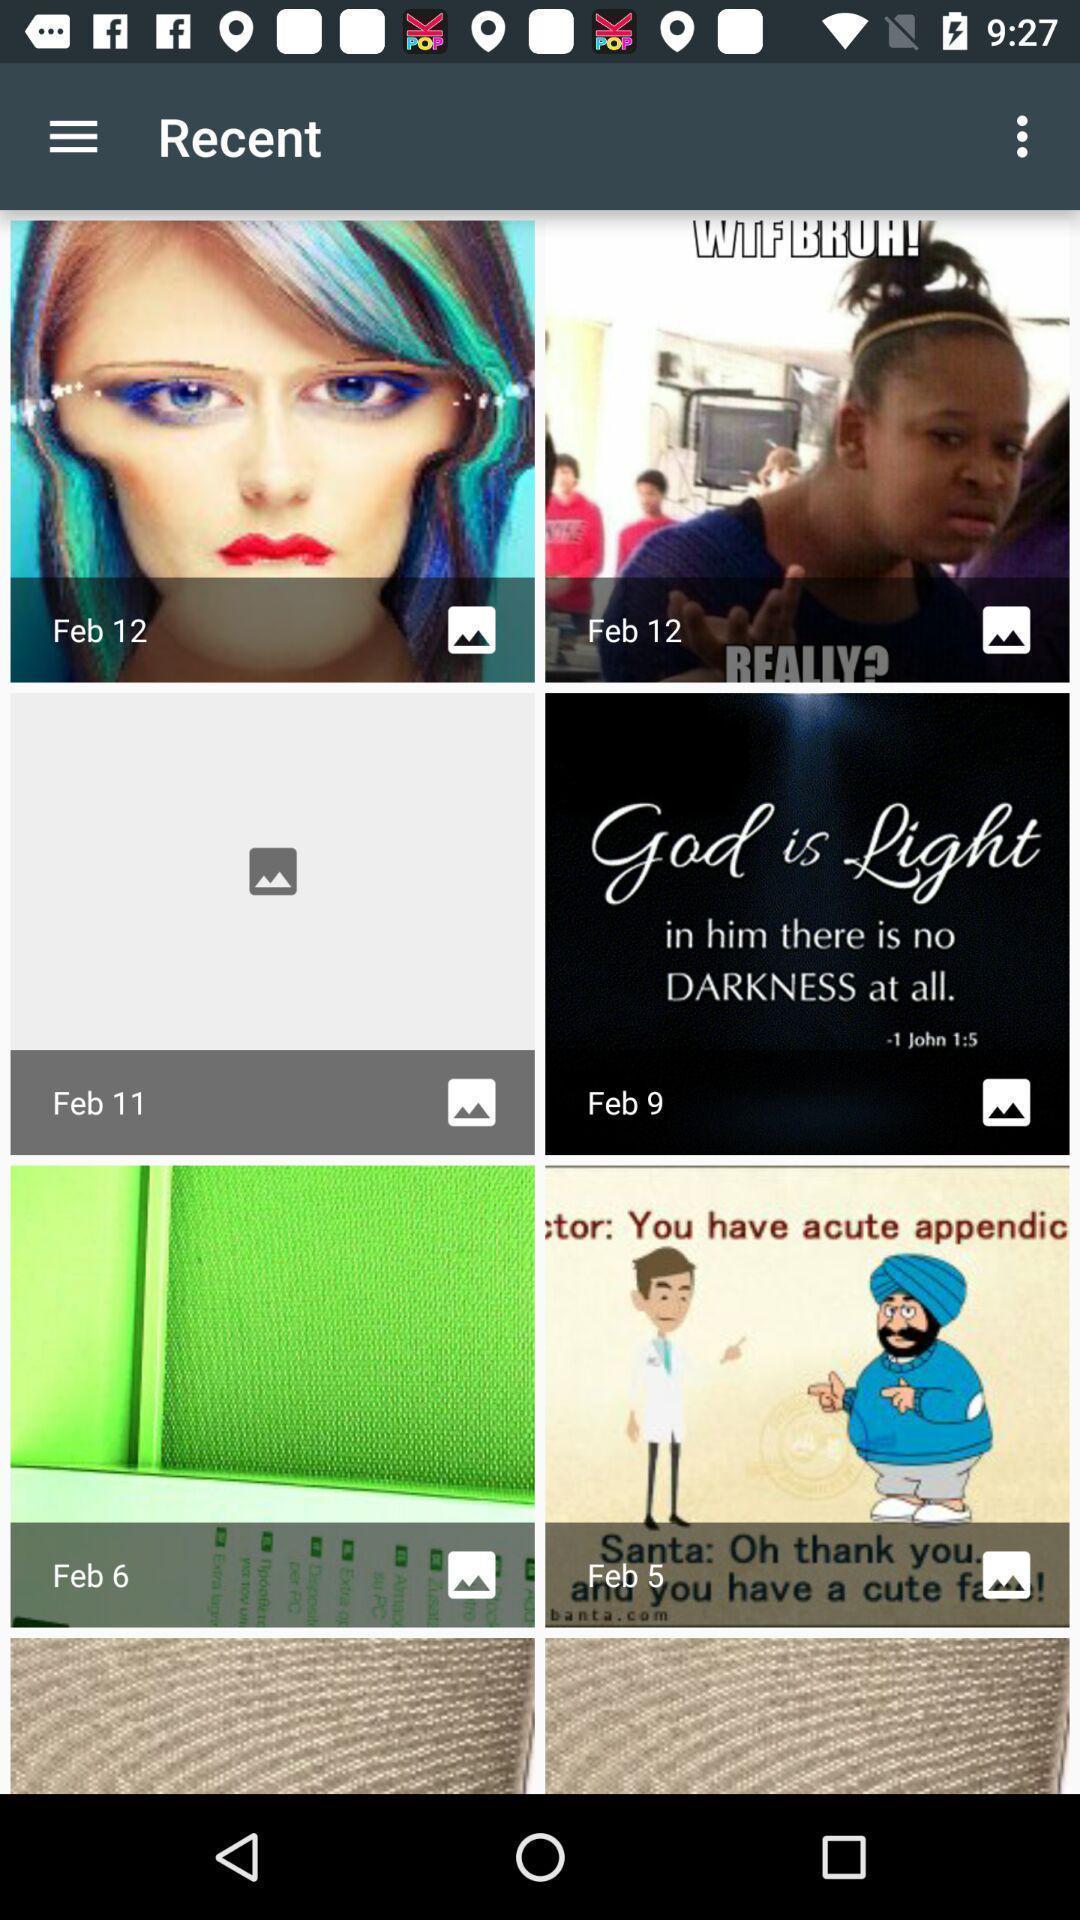Summarize the main components in this picture. Set of pictures in an online fund raising app. 